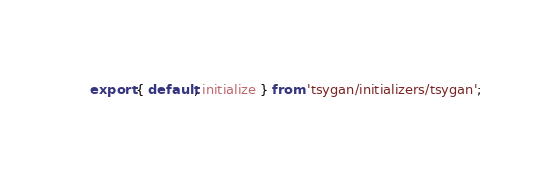<code> <loc_0><loc_0><loc_500><loc_500><_JavaScript_>export { default, initialize } from 'tsygan/initializers/tsygan';
</code> 